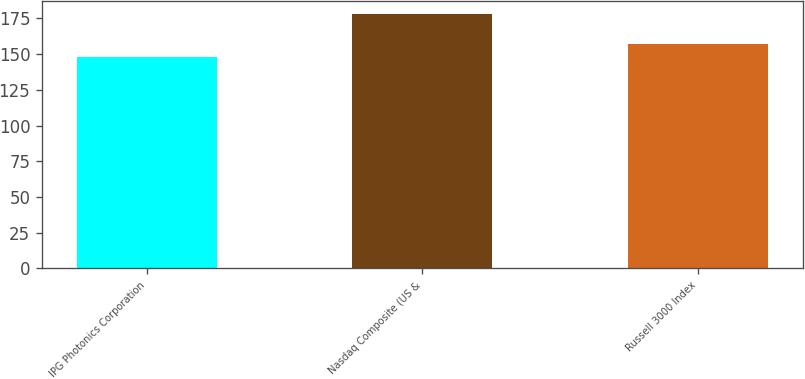Convert chart to OTSL. <chart><loc_0><loc_0><loc_500><loc_500><bar_chart><fcel>IPG Photonics Corporation<fcel>Nasdaq Composite (US &<fcel>Russell 3000 Index<nl><fcel>148.1<fcel>178.28<fcel>157.34<nl></chart> 